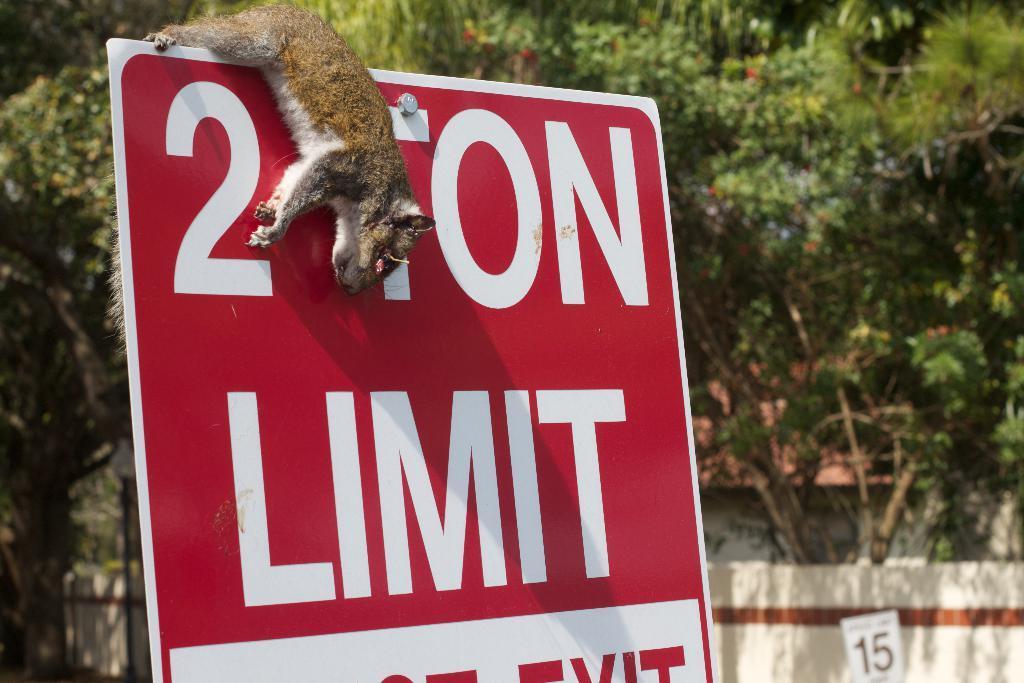How would you summarize this image in a sentence or two? In the foreground I can see a board and an animal is hanging on it. In the background I can see trees, fence, pole and house. This image is taken may be during a day. 